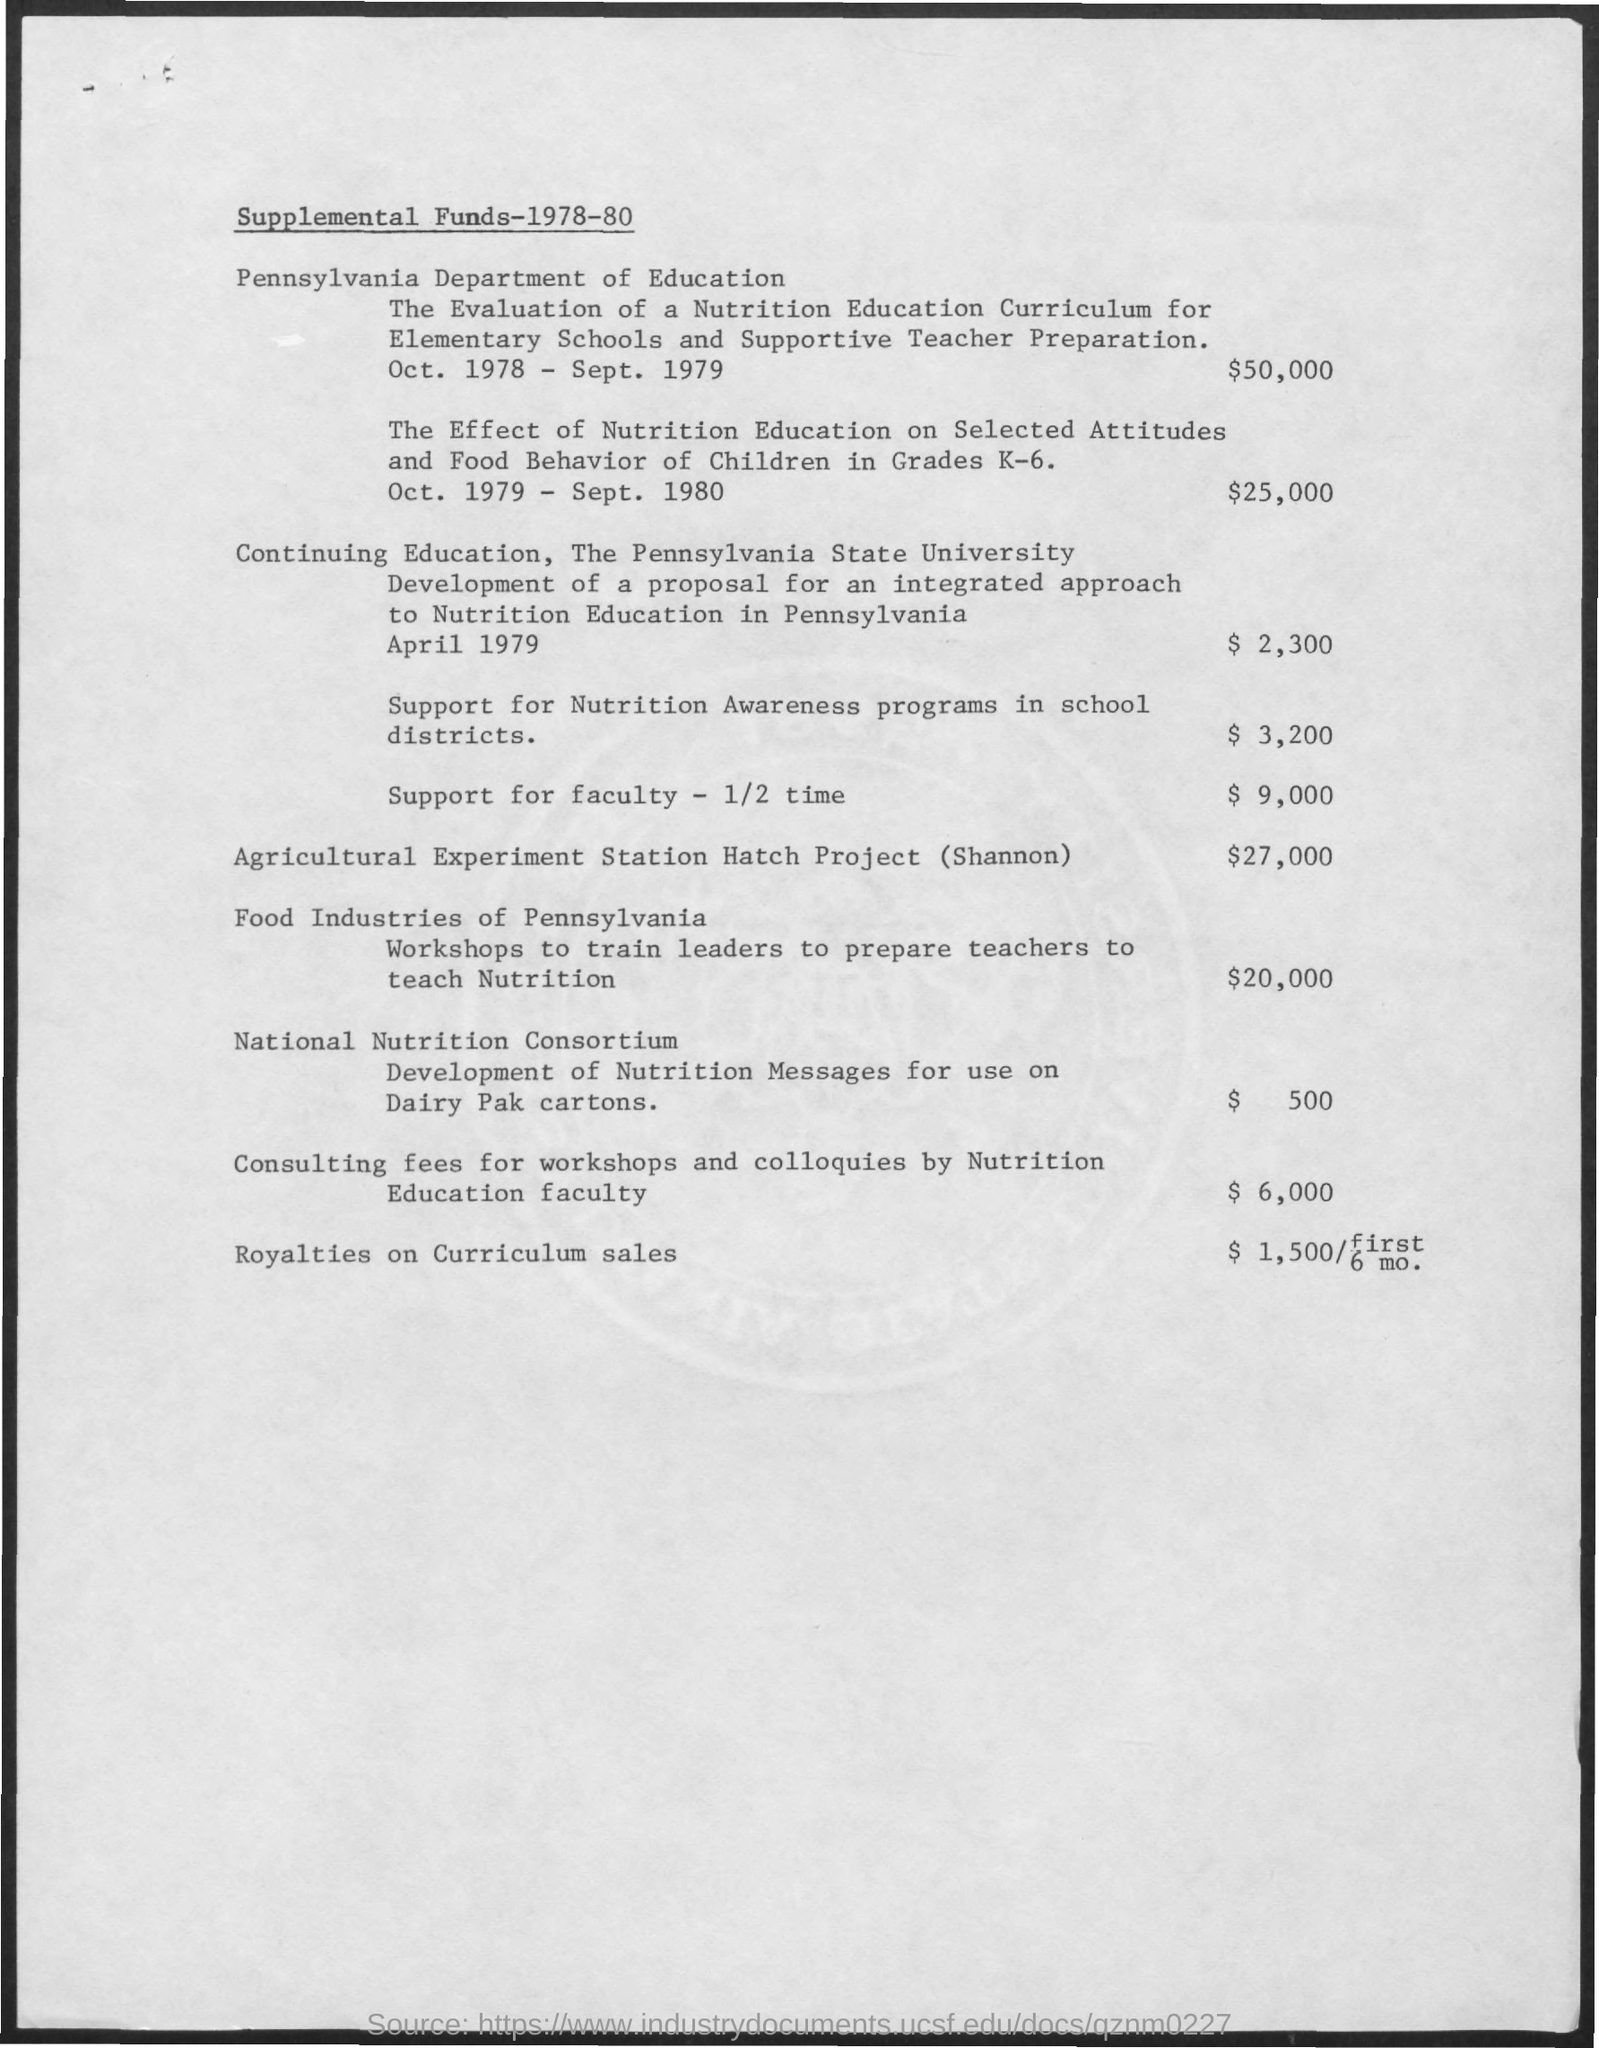What is the amount of fund mentioned for agricultural experiment station hatch project(shannon) ?
Keep it short and to the point. $ 27,000. What is the amount of fund for support for nutrition awareness programs in school districts ?
Your answer should be very brief. $ 3,200. What is the amount of fund for support for faculty -1/2 times?
Provide a short and direct response. $ 9,000. 